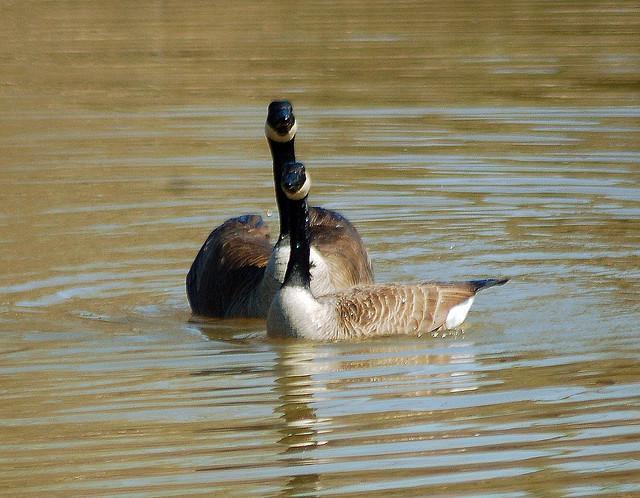How many geese are in the picture?
Give a very brief answer. 2. How many birds are depicted?
Give a very brief answer. 2. How many birds are there?
Give a very brief answer. 2. 